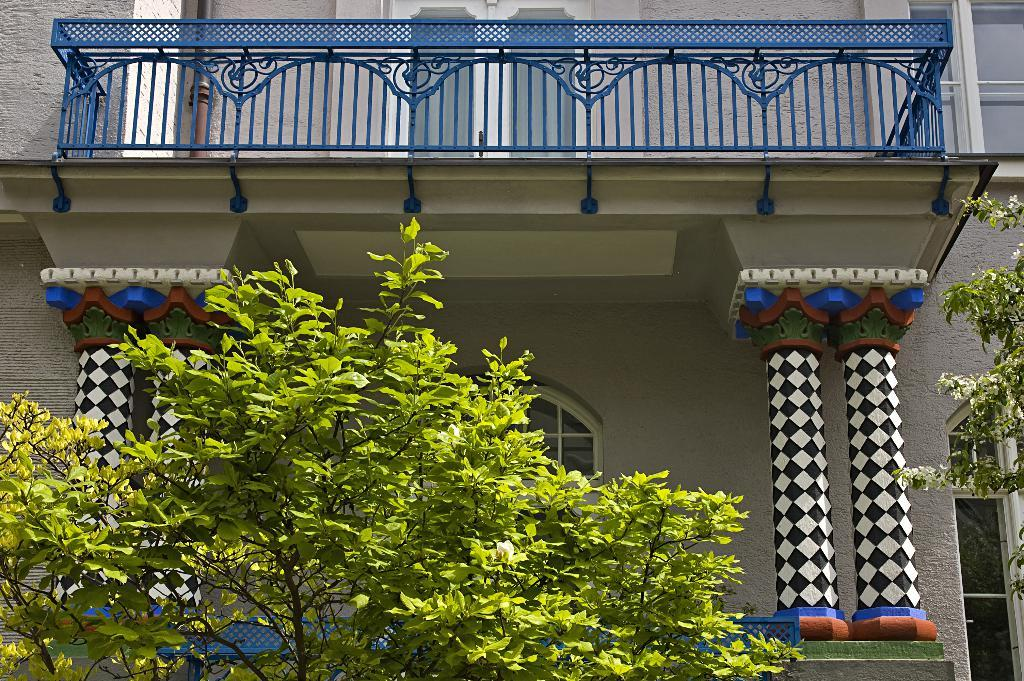What is the main subject in the center of the image? There is a building in the center of the image. What can be seen in the foreground of the image? There are plants in the foreground of the image. What architectural features are present on both sides of the image? There are pillars on both the right and left sides of the image. What can be seen through the windows in the image? There are windows visible on both the right and left sides of the image. What type of soup is being served in the image? There is no soup present in the image. 